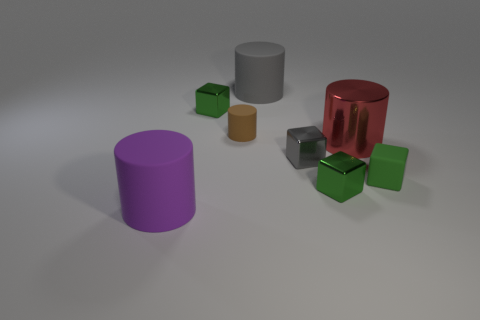What number of other objects are there of the same color as the large metallic thing?
Give a very brief answer. 0. There is a block on the left side of the gray rubber object; does it have the same size as the large gray rubber cylinder?
Provide a short and direct response. No. Is the cube that is left of the big gray cylinder made of the same material as the gray thing that is in front of the red object?
Provide a succinct answer. Yes. Is there a red object of the same size as the gray rubber cylinder?
Provide a succinct answer. Yes. What shape is the big thing that is to the right of the tiny metallic thing in front of the object that is to the right of the large red metal cylinder?
Offer a terse response. Cylinder. Are there more metallic cubes that are to the right of the gray matte cylinder than blue things?
Offer a very short reply. Yes. Is there a brown thing that has the same shape as the gray matte object?
Offer a very short reply. Yes. Do the purple object and the gray thing left of the gray metal thing have the same material?
Your answer should be compact. Yes. What is the color of the small cylinder?
Provide a short and direct response. Brown. What number of big matte cylinders are to the left of the large thing behind the green cube that is behind the small green matte cube?
Offer a terse response. 1. 